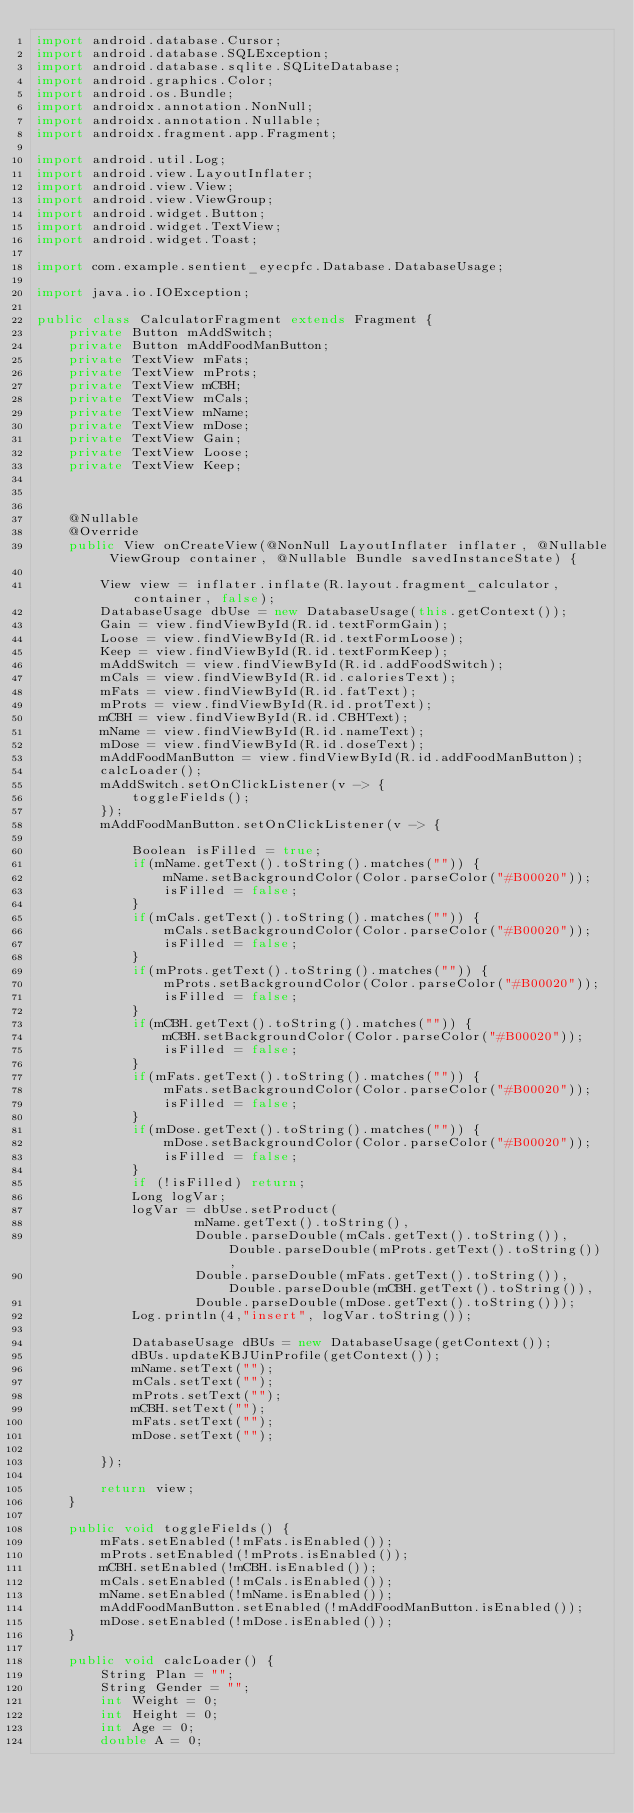<code> <loc_0><loc_0><loc_500><loc_500><_Java_>import android.database.Cursor;
import android.database.SQLException;
import android.database.sqlite.SQLiteDatabase;
import android.graphics.Color;
import android.os.Bundle;
import androidx.annotation.NonNull;
import androidx.annotation.Nullable;
import androidx.fragment.app.Fragment;

import android.util.Log;
import android.view.LayoutInflater;
import android.view.View;
import android.view.ViewGroup;
import android.widget.Button;
import android.widget.TextView;
import android.widget.Toast;

import com.example.sentient_eyecpfc.Database.DatabaseUsage;

import java.io.IOException;

public class CalculatorFragment extends Fragment {
    private Button mAddSwitch;
    private Button mAddFoodManButton;
    private TextView mFats;
    private TextView mProts;
    private TextView mCBH;
    private TextView mCals;
    private TextView mName;
    private TextView mDose;
    private TextView Gain;
    private TextView Loose;
    private TextView Keep;



    @Nullable
    @Override
    public View onCreateView(@NonNull LayoutInflater inflater, @Nullable ViewGroup container, @Nullable Bundle savedInstanceState) {

        View view = inflater.inflate(R.layout.fragment_calculator, container, false);
        DatabaseUsage dbUse = new DatabaseUsage(this.getContext());
        Gain = view.findViewById(R.id.textFormGain);
        Loose = view.findViewById(R.id.textFormLoose);
        Keep = view.findViewById(R.id.textFormKeep);
        mAddSwitch = view.findViewById(R.id.addFoodSwitch);
        mCals = view.findViewById(R.id.caloriesText);
        mFats = view.findViewById(R.id.fatText);
        mProts = view.findViewById(R.id.protText);
        mCBH = view.findViewById(R.id.CBHText);
        mName = view.findViewById(R.id.nameText);
        mDose = view.findViewById(R.id.doseText);
        mAddFoodManButton = view.findViewById(R.id.addFoodManButton);
        calcLoader();
        mAddSwitch.setOnClickListener(v -> {
            toggleFields();
        });
        mAddFoodManButton.setOnClickListener(v -> {

            Boolean isFilled = true;
            if(mName.getText().toString().matches("")) {
                mName.setBackgroundColor(Color.parseColor("#B00020"));
                isFilled = false;
            }
            if(mCals.getText().toString().matches("")) {
                mCals.setBackgroundColor(Color.parseColor("#B00020"));
                isFilled = false;
            }
            if(mProts.getText().toString().matches("")) {
                mProts.setBackgroundColor(Color.parseColor("#B00020"));
                isFilled = false;
            }
            if(mCBH.getText().toString().matches("")) {
                mCBH.setBackgroundColor(Color.parseColor("#B00020"));
                isFilled = false;
            }
            if(mFats.getText().toString().matches("")) {
                mFats.setBackgroundColor(Color.parseColor("#B00020"));
                isFilled = false;
            }
            if(mDose.getText().toString().matches("")) {
                mDose.setBackgroundColor(Color.parseColor("#B00020"));
                isFilled = false;
            }
            if (!isFilled) return;
            Long logVar;
            logVar = dbUse.setProduct(
                    mName.getText().toString(),
                    Double.parseDouble(mCals.getText().toString()), Double.parseDouble(mProts.getText().toString()),
                    Double.parseDouble(mFats.getText().toString()), Double.parseDouble(mCBH.getText().toString()),
                    Double.parseDouble(mDose.getText().toString()));
            Log.println(4,"insert", logVar.toString());

            DatabaseUsage dBUs = new DatabaseUsage(getContext());
            dBUs.updateKBJUinProfile(getContext());
            mName.setText("");
            mCals.setText("");
            mProts.setText("");
            mCBH.setText("");
            mFats.setText("");
            mDose.setText("");

        });

        return view;
    }

    public void toggleFields() {
        mFats.setEnabled(!mFats.isEnabled());
        mProts.setEnabled(!mProts.isEnabled());
        mCBH.setEnabled(!mCBH.isEnabled());
        mCals.setEnabled(!mCals.isEnabled());
        mName.setEnabled(!mName.isEnabled());
        mAddFoodManButton.setEnabled(!mAddFoodManButton.isEnabled());
        mDose.setEnabled(!mDose.isEnabled());
    }

    public void calcLoader() {
        String Plan = "";
        String Gender = "";
        int Weight = 0;
        int Height = 0;
        int Age = 0;
        double A = 0;</code> 